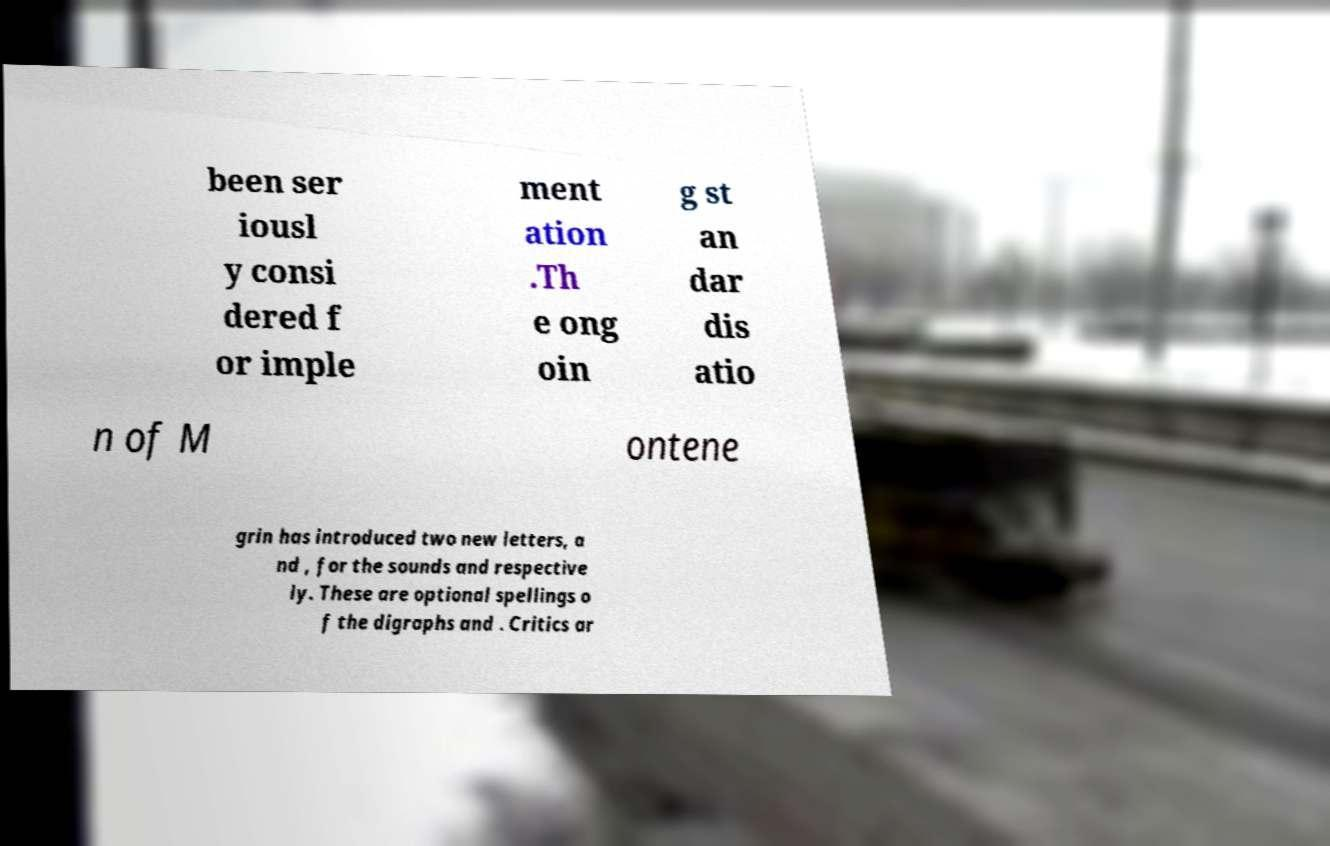Could you assist in decoding the text presented in this image and type it out clearly? been ser iousl y consi dered f or imple ment ation .Th e ong oin g st an dar dis atio n of M ontene grin has introduced two new letters, a nd , for the sounds and respective ly. These are optional spellings o f the digraphs and . Critics ar 